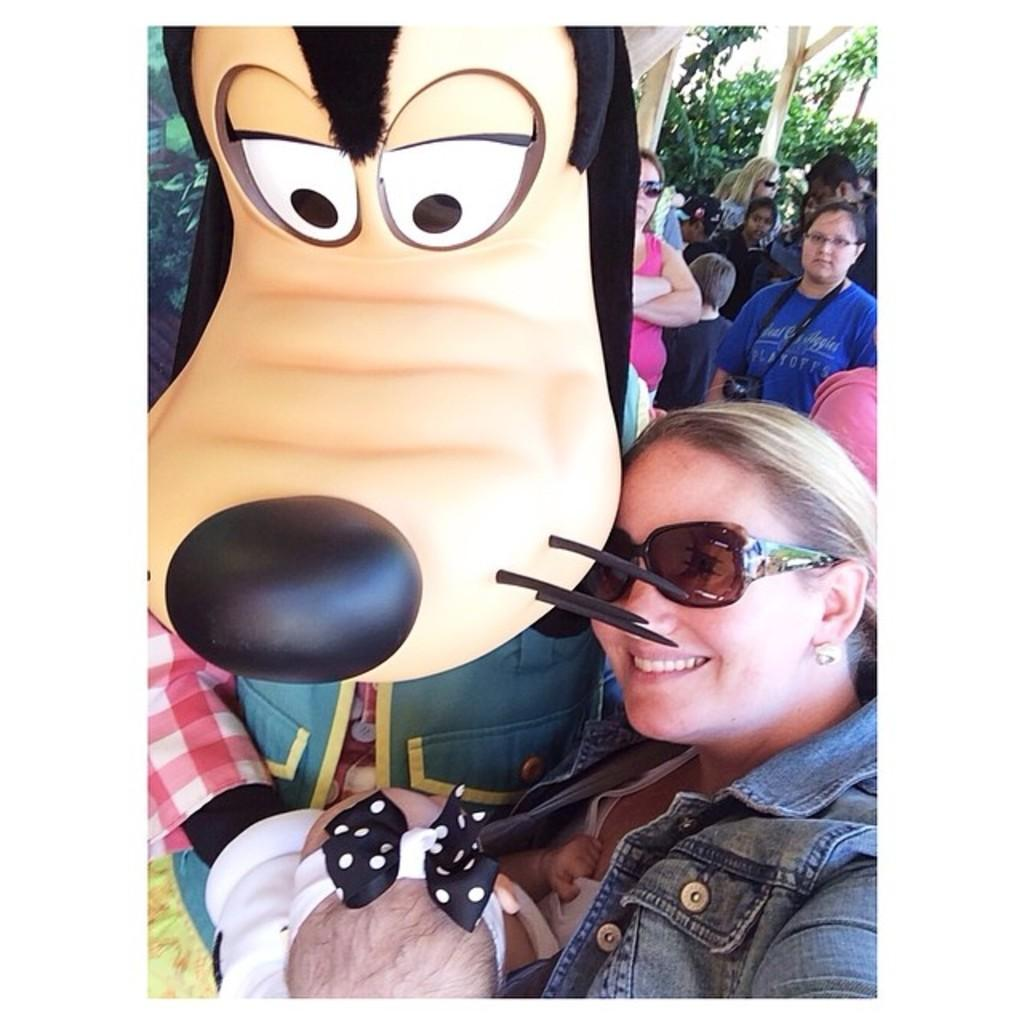What is the main subject in the image? There is a mascot in the image. What is the woman in the image doing? The woman is carrying a baby in the image. What can be seen in the background of the image? There is a group of people and plants in the background of the image. Can you see the ocean in the background of the image? No, there is no ocean visible in the image. 